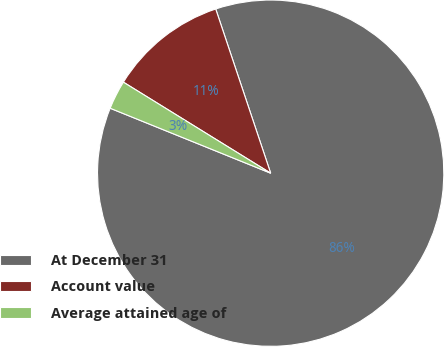Convert chart to OTSL. <chart><loc_0><loc_0><loc_500><loc_500><pie_chart><fcel>At December 31<fcel>Account value<fcel>Average attained age of<nl><fcel>86.26%<fcel>11.05%<fcel>2.69%<nl></chart> 